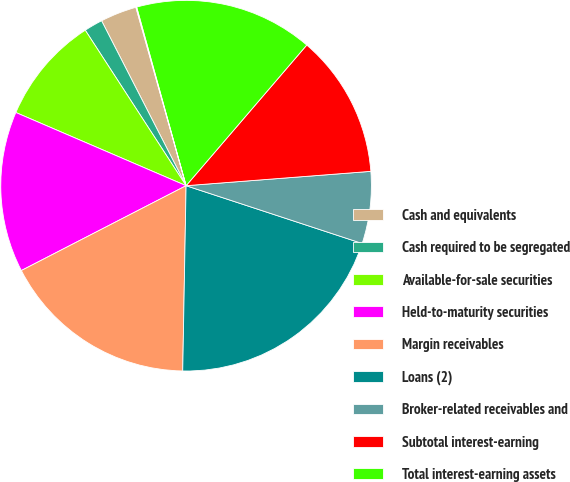Convert chart. <chart><loc_0><loc_0><loc_500><loc_500><pie_chart><fcel>Cash and equivalents<fcel>Cash required to be segregated<fcel>Available-for-sale securities<fcel>Held-to-maturity securities<fcel>Margin receivables<fcel>Loans (2)<fcel>Broker-related receivables and<fcel>Subtotal interest-earning<fcel>Total interest-earning assets<fcel>Sweep deposits<nl><fcel>3.17%<fcel>1.62%<fcel>9.38%<fcel>14.03%<fcel>17.14%<fcel>20.24%<fcel>6.28%<fcel>12.48%<fcel>15.58%<fcel>0.07%<nl></chart> 